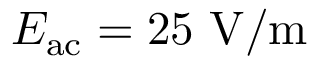Convert formula to latex. <formula><loc_0><loc_0><loc_500><loc_500>E _ { a c } = 2 5 V / m</formula> 